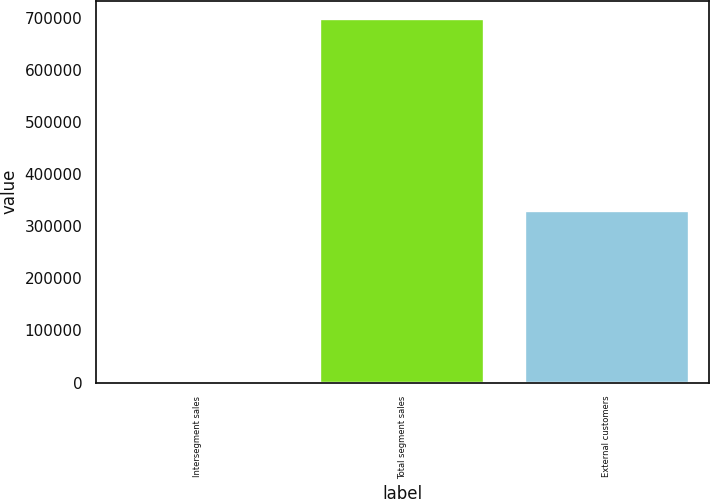<chart> <loc_0><loc_0><loc_500><loc_500><bar_chart><fcel>Intersegment sales<fcel>Total segment sales<fcel>External customers<nl><fcel>1061<fcel>697702<fcel>328514<nl></chart> 